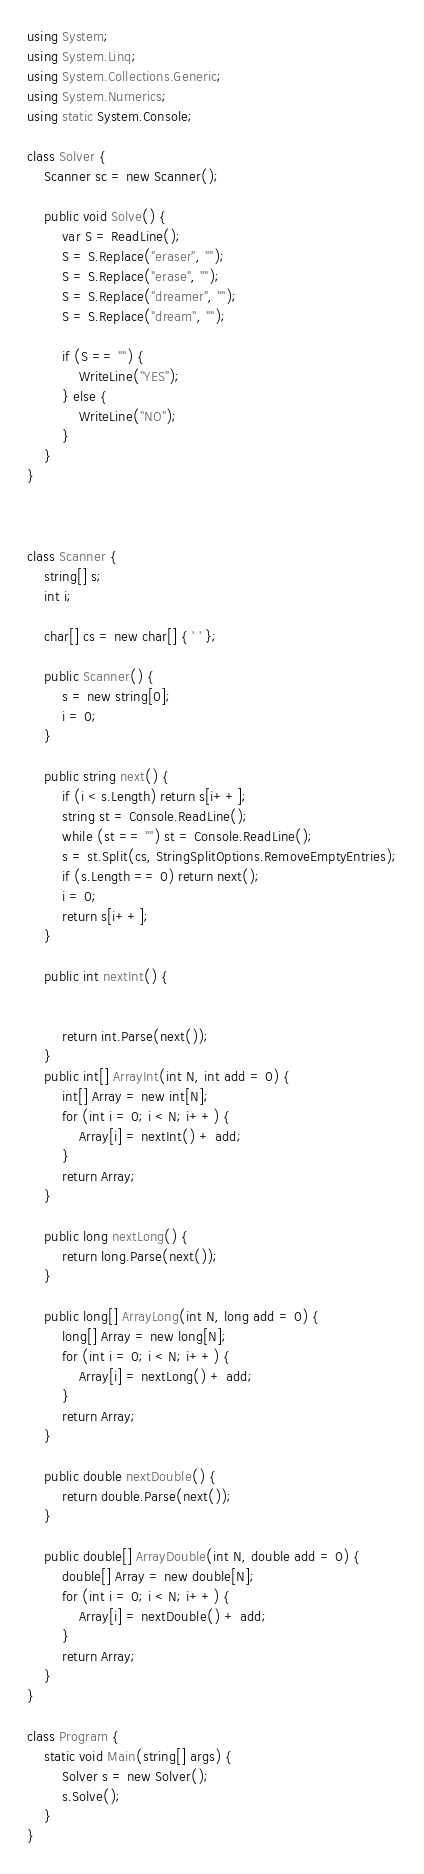<code> <loc_0><loc_0><loc_500><loc_500><_C#_>using System;
using System.Linq;
using System.Collections.Generic;
using System.Numerics;
using static System.Console;

class Solver {
    Scanner sc = new Scanner();

    public void Solve() {
        var S = ReadLine();
        S = S.Replace("eraser", "");
        S = S.Replace("erase", "");
        S = S.Replace("dreamer", "");
        S = S.Replace("dream", "");

        if (S == "") {
            WriteLine("YES");
        } else {
            WriteLine("NO");
        }
    }
}



class Scanner {
    string[] s;
    int i;

    char[] cs = new char[] { ' ' };

    public Scanner() {
        s = new string[0];
        i = 0;
    }

    public string next() {
        if (i < s.Length) return s[i++];
        string st = Console.ReadLine();
        while (st == "") st = Console.ReadLine();
        s = st.Split(cs, StringSplitOptions.RemoveEmptyEntries);
        if (s.Length == 0) return next();
        i = 0;
        return s[i++];
    }

    public int nextInt() {


        return int.Parse(next());
    }
    public int[] ArrayInt(int N, int add = 0) {
        int[] Array = new int[N];
        for (int i = 0; i < N; i++) {
            Array[i] = nextInt() + add;
        }
        return Array;
    }

    public long nextLong() {
        return long.Parse(next());
    }

    public long[] ArrayLong(int N, long add = 0) {
        long[] Array = new long[N];
        for (int i = 0; i < N; i++) {
            Array[i] = nextLong() + add;
        }
        return Array;
    }

    public double nextDouble() {
        return double.Parse(next());
    }

    public double[] ArrayDouble(int N, double add = 0) {
        double[] Array = new double[N];
        for (int i = 0; i < N; i++) {
            Array[i] = nextDouble() + add;
        }
        return Array;
    }
}

class Program {
    static void Main(string[] args) {
        Solver s = new Solver();
        s.Solve();
    }
}</code> 